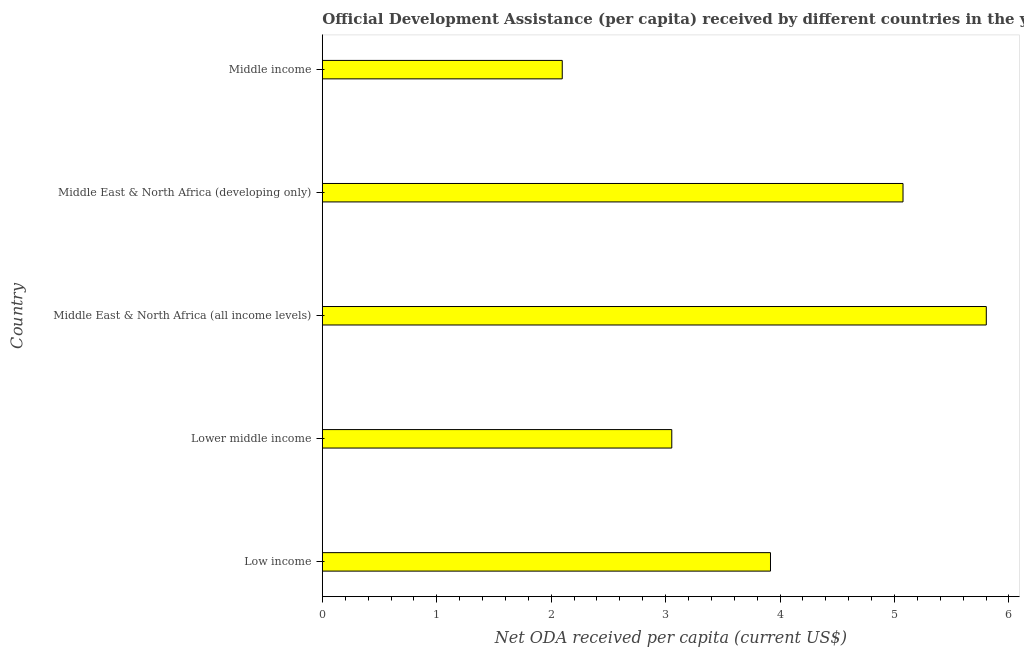Does the graph contain any zero values?
Provide a short and direct response. No. What is the title of the graph?
Ensure brevity in your answer.  Official Development Assistance (per capita) received by different countries in the year 1966. What is the label or title of the X-axis?
Make the answer very short. Net ODA received per capita (current US$). What is the net oda received per capita in Middle income?
Keep it short and to the point. 2.1. Across all countries, what is the maximum net oda received per capita?
Ensure brevity in your answer.  5.8. Across all countries, what is the minimum net oda received per capita?
Your answer should be compact. 2.1. In which country was the net oda received per capita maximum?
Keep it short and to the point. Middle East & North Africa (all income levels). What is the sum of the net oda received per capita?
Your answer should be very brief. 19.94. What is the difference between the net oda received per capita in Lower middle income and Middle income?
Make the answer very short. 0.96. What is the average net oda received per capita per country?
Your response must be concise. 3.99. What is the median net oda received per capita?
Make the answer very short. 3.92. In how many countries, is the net oda received per capita greater than 1.6 US$?
Offer a terse response. 5. What is the ratio of the net oda received per capita in Lower middle income to that in Middle income?
Your answer should be compact. 1.46. Is the net oda received per capita in Low income less than that in Middle East & North Africa (all income levels)?
Offer a terse response. Yes. Is the difference between the net oda received per capita in Low income and Middle East & North Africa (all income levels) greater than the difference between any two countries?
Keep it short and to the point. No. What is the difference between the highest and the second highest net oda received per capita?
Provide a short and direct response. 0.73. What is the difference between the highest and the lowest net oda received per capita?
Provide a short and direct response. 3.71. In how many countries, is the net oda received per capita greater than the average net oda received per capita taken over all countries?
Your answer should be compact. 2. Are all the bars in the graph horizontal?
Your answer should be compact. Yes. How many countries are there in the graph?
Keep it short and to the point. 5. What is the difference between two consecutive major ticks on the X-axis?
Your answer should be very brief. 1. What is the Net ODA received per capita (current US$) of Low income?
Offer a terse response. 3.92. What is the Net ODA received per capita (current US$) in Lower middle income?
Your answer should be very brief. 3.05. What is the Net ODA received per capita (current US$) of Middle East & North Africa (all income levels)?
Provide a short and direct response. 5.8. What is the Net ODA received per capita (current US$) in Middle East & North Africa (developing only)?
Your response must be concise. 5.07. What is the Net ODA received per capita (current US$) of Middle income?
Make the answer very short. 2.1. What is the difference between the Net ODA received per capita (current US$) in Low income and Lower middle income?
Your response must be concise. 0.86. What is the difference between the Net ODA received per capita (current US$) in Low income and Middle East & North Africa (all income levels)?
Offer a very short reply. -1.89. What is the difference between the Net ODA received per capita (current US$) in Low income and Middle East & North Africa (developing only)?
Ensure brevity in your answer.  -1.16. What is the difference between the Net ODA received per capita (current US$) in Low income and Middle income?
Your answer should be very brief. 1.82. What is the difference between the Net ODA received per capita (current US$) in Lower middle income and Middle East & North Africa (all income levels)?
Give a very brief answer. -2.75. What is the difference between the Net ODA received per capita (current US$) in Lower middle income and Middle East & North Africa (developing only)?
Give a very brief answer. -2.02. What is the difference between the Net ODA received per capita (current US$) in Lower middle income and Middle income?
Offer a very short reply. 0.96. What is the difference between the Net ODA received per capita (current US$) in Middle East & North Africa (all income levels) and Middle East & North Africa (developing only)?
Offer a very short reply. 0.73. What is the difference between the Net ODA received per capita (current US$) in Middle East & North Africa (all income levels) and Middle income?
Your answer should be very brief. 3.71. What is the difference between the Net ODA received per capita (current US$) in Middle East & North Africa (developing only) and Middle income?
Your answer should be very brief. 2.98. What is the ratio of the Net ODA received per capita (current US$) in Low income to that in Lower middle income?
Ensure brevity in your answer.  1.28. What is the ratio of the Net ODA received per capita (current US$) in Low income to that in Middle East & North Africa (all income levels)?
Make the answer very short. 0.68. What is the ratio of the Net ODA received per capita (current US$) in Low income to that in Middle East & North Africa (developing only)?
Provide a short and direct response. 0.77. What is the ratio of the Net ODA received per capita (current US$) in Low income to that in Middle income?
Offer a terse response. 1.87. What is the ratio of the Net ODA received per capita (current US$) in Lower middle income to that in Middle East & North Africa (all income levels)?
Your answer should be compact. 0.53. What is the ratio of the Net ODA received per capita (current US$) in Lower middle income to that in Middle East & North Africa (developing only)?
Provide a succinct answer. 0.6. What is the ratio of the Net ODA received per capita (current US$) in Lower middle income to that in Middle income?
Offer a terse response. 1.46. What is the ratio of the Net ODA received per capita (current US$) in Middle East & North Africa (all income levels) to that in Middle East & North Africa (developing only)?
Make the answer very short. 1.14. What is the ratio of the Net ODA received per capita (current US$) in Middle East & North Africa (all income levels) to that in Middle income?
Give a very brief answer. 2.77. What is the ratio of the Net ODA received per capita (current US$) in Middle East & North Africa (developing only) to that in Middle income?
Give a very brief answer. 2.42. 